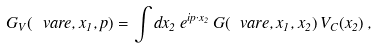Convert formula to latex. <formula><loc_0><loc_0><loc_500><loc_500>G _ { V } ( \ v a r e , x _ { 1 } , p ) = \int d x _ { 2 } \, e ^ { i p \cdot x _ { 2 } } \, G ( \ v a r e , x _ { 1 } , x _ { 2 } ) \, V _ { C } ( x _ { 2 } ) \, ,</formula> 